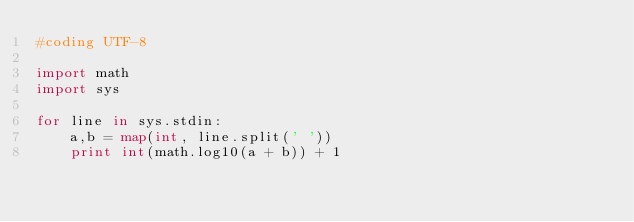Convert code to text. <code><loc_0><loc_0><loc_500><loc_500><_Python_>#coding UTF-8

import math
import sys

for line in sys.stdin:
	a,b = map(int, line.split(' '))
	print int(math.log10(a + b)) + 1</code> 